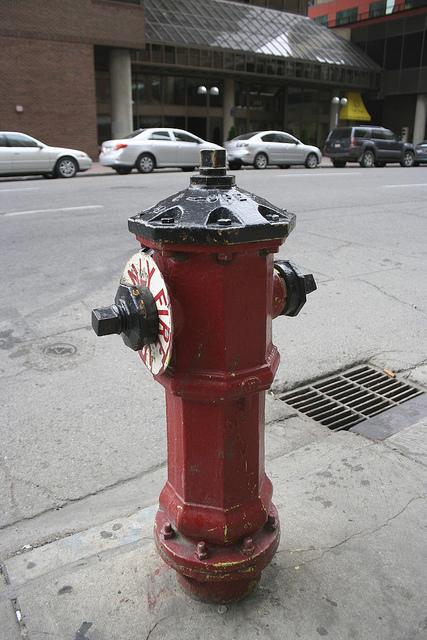What is the safety device in the foreground used to help defeat?

Choices:
A) getaway cars
B) paper cuts
C) fires
D) vulture infestation fires 